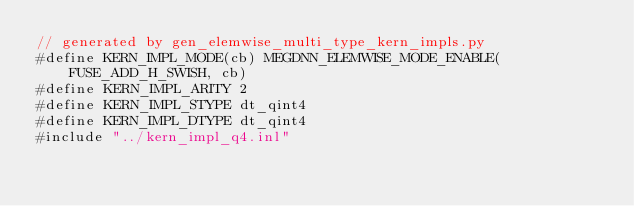Convert code to text. <code><loc_0><loc_0><loc_500><loc_500><_Cuda_>// generated by gen_elemwise_multi_type_kern_impls.py
#define KERN_IMPL_MODE(cb) MEGDNN_ELEMWISE_MODE_ENABLE(FUSE_ADD_H_SWISH, cb)
#define KERN_IMPL_ARITY 2
#define KERN_IMPL_STYPE dt_qint4
#define KERN_IMPL_DTYPE dt_qint4
#include "../kern_impl_q4.inl"
</code> 